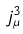Convert formula to latex. <formula><loc_0><loc_0><loc_500><loc_500>j _ { \mu } ^ { 3 }</formula> 